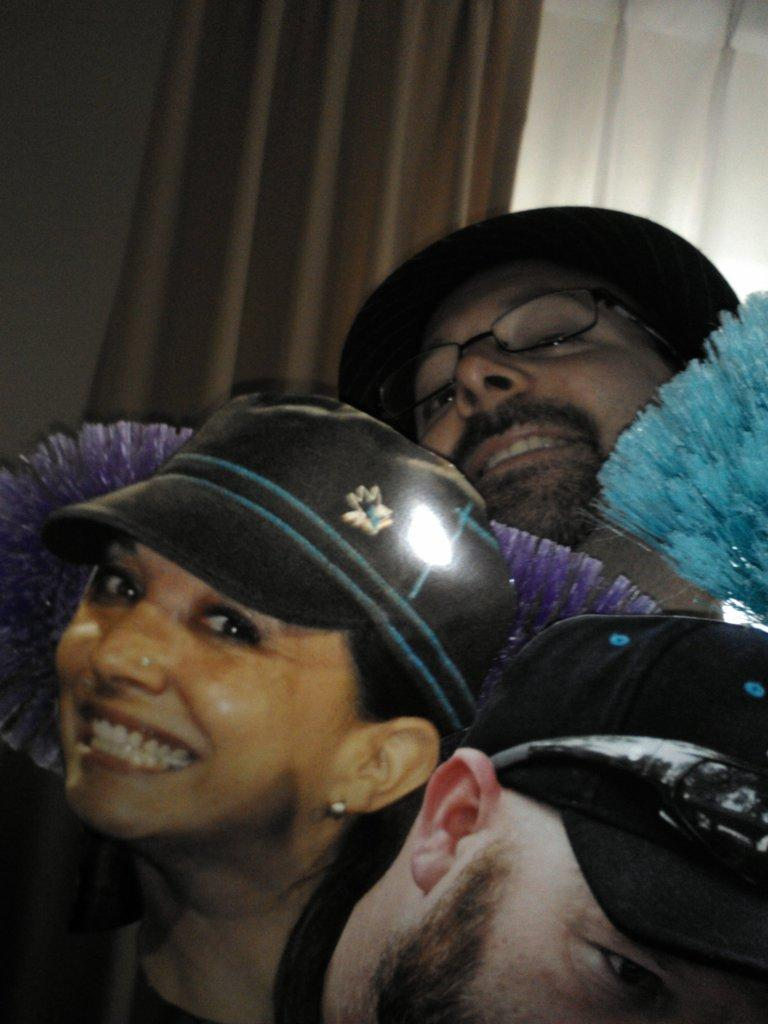How many people are in the image? There are three persons in the image. What are the persons wearing on their heads? The persons are wearing caps. Can you describe any objects between the persons? Yes, there are other objects between the persons. What can be seen in the background of the image? There is a curtain in the background of the image. What type of appliance is being used by the persons in the image? There is no appliance visible in the image; the persons are wearing caps and there are objects between them. 